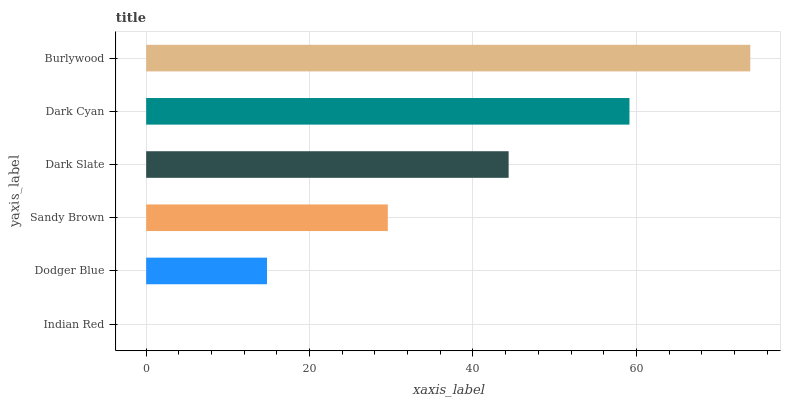Is Indian Red the minimum?
Answer yes or no. Yes. Is Burlywood the maximum?
Answer yes or no. Yes. Is Dodger Blue the minimum?
Answer yes or no. No. Is Dodger Blue the maximum?
Answer yes or no. No. Is Dodger Blue greater than Indian Red?
Answer yes or no. Yes. Is Indian Red less than Dodger Blue?
Answer yes or no. Yes. Is Indian Red greater than Dodger Blue?
Answer yes or no. No. Is Dodger Blue less than Indian Red?
Answer yes or no. No. Is Dark Slate the high median?
Answer yes or no. Yes. Is Sandy Brown the low median?
Answer yes or no. Yes. Is Sandy Brown the high median?
Answer yes or no. No. Is Indian Red the low median?
Answer yes or no. No. 